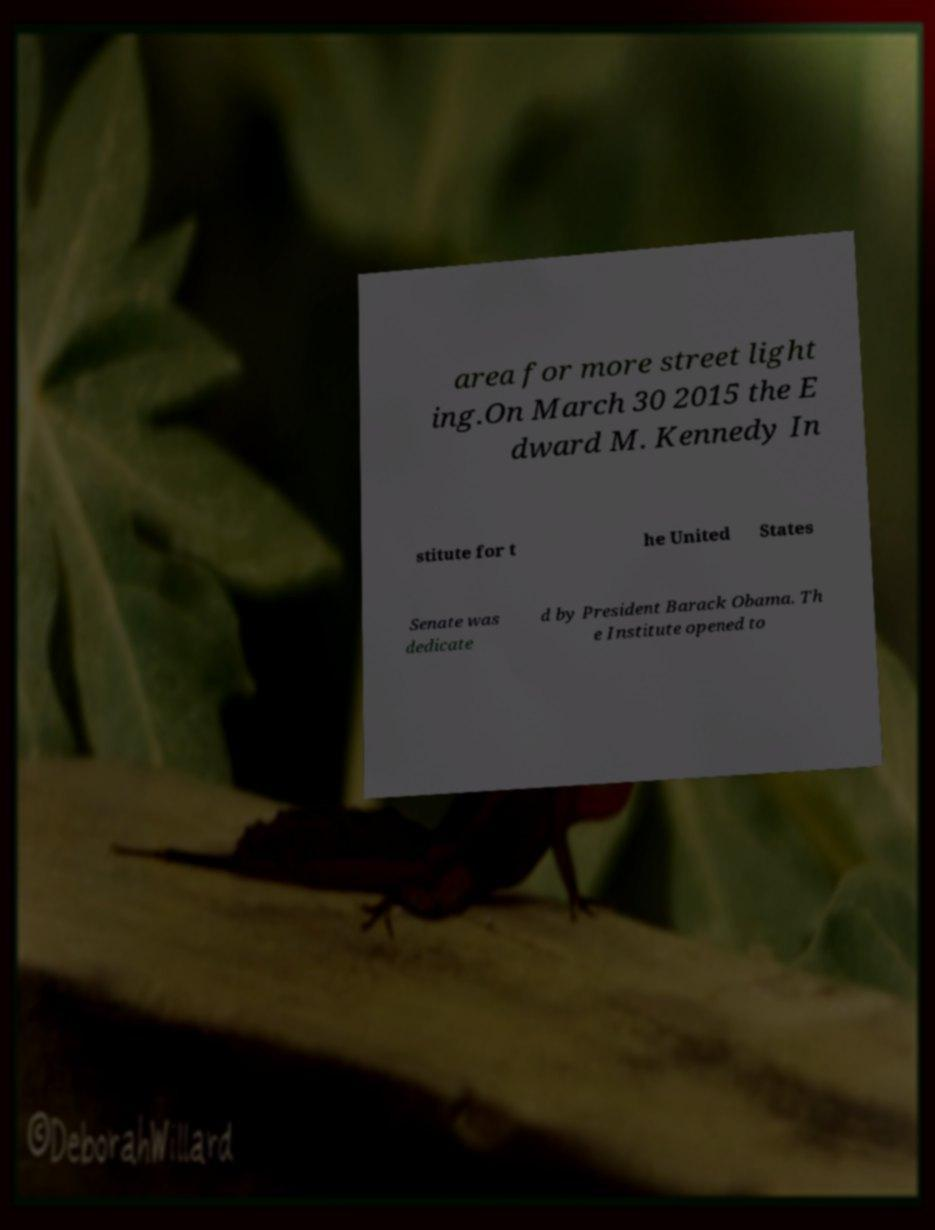Can you read and provide the text displayed in the image?This photo seems to have some interesting text. Can you extract and type it out for me? area for more street light ing.On March 30 2015 the E dward M. Kennedy In stitute for t he United States Senate was dedicate d by President Barack Obama. Th e Institute opened to 